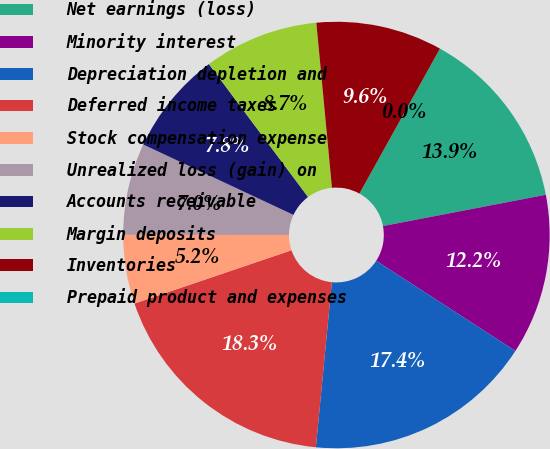<chart> <loc_0><loc_0><loc_500><loc_500><pie_chart><fcel>Net earnings (loss)<fcel>Minority interest<fcel>Depreciation depletion and<fcel>Deferred income taxes<fcel>Stock compensation expense<fcel>Unrealized loss (gain) on<fcel>Accounts receivable<fcel>Margin deposits<fcel>Inventories<fcel>Prepaid product and expenses<nl><fcel>13.91%<fcel>12.17%<fcel>17.39%<fcel>18.26%<fcel>5.22%<fcel>6.96%<fcel>7.83%<fcel>8.7%<fcel>9.57%<fcel>0.0%<nl></chart> 